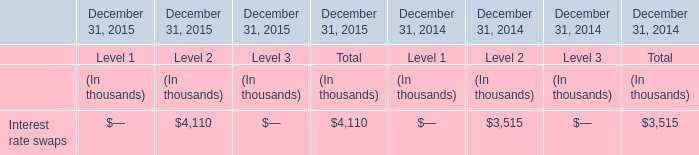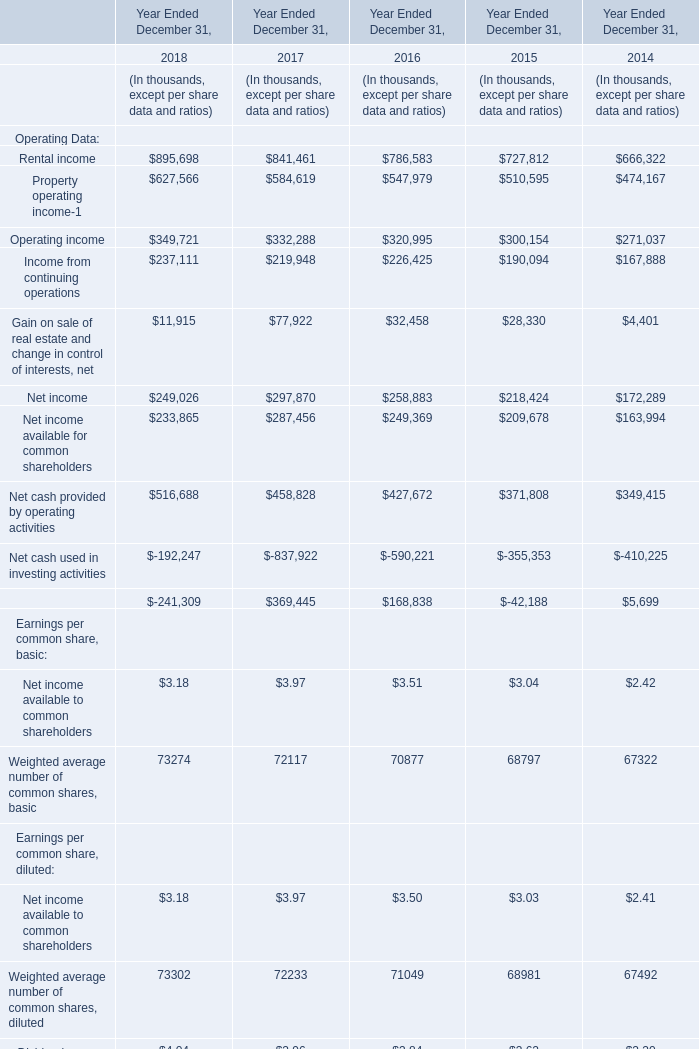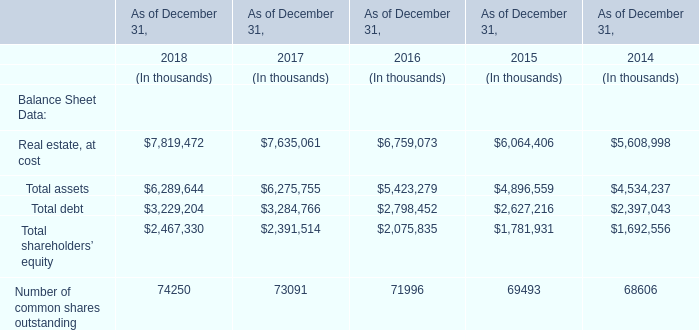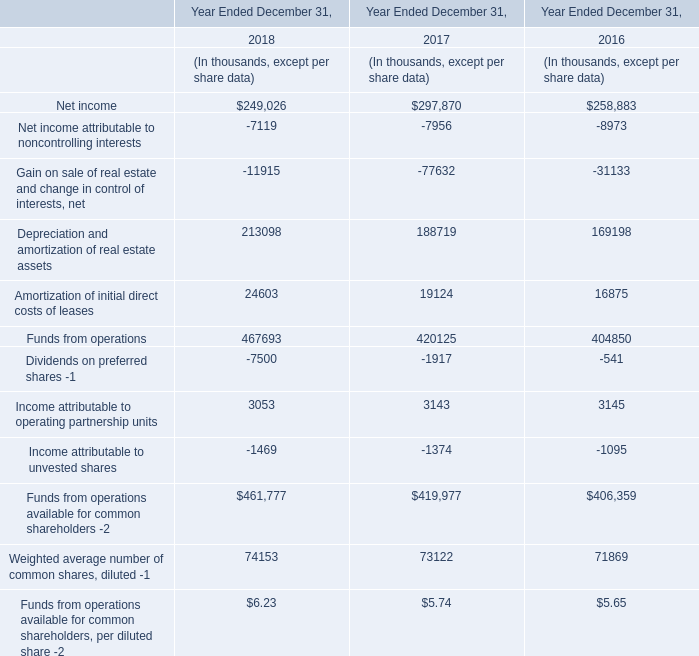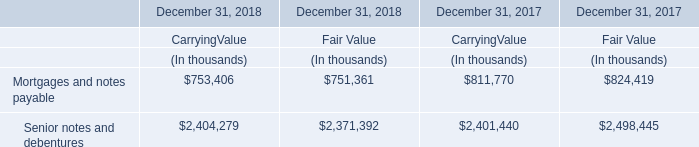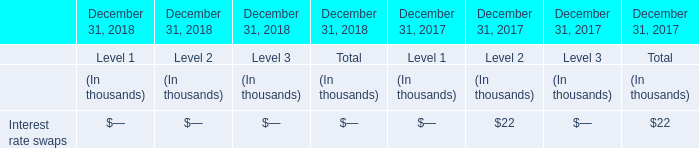What's the growth rate of rental income in 2018? (in %) 
Computations: ((895698 - 841461) / 841461)
Answer: 0.06446. 